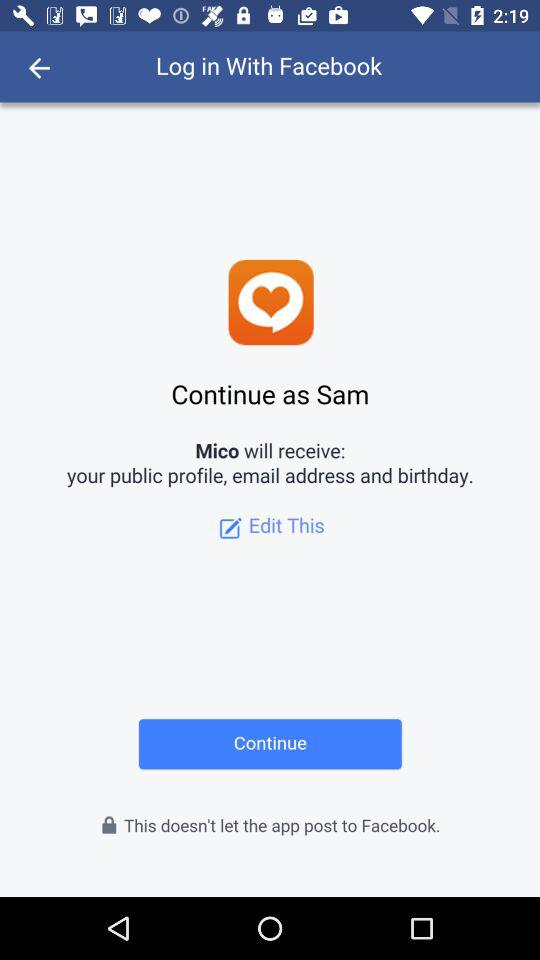What is the user's last name?
When the provided information is insufficient, respond with <no answer>. <no answer> 